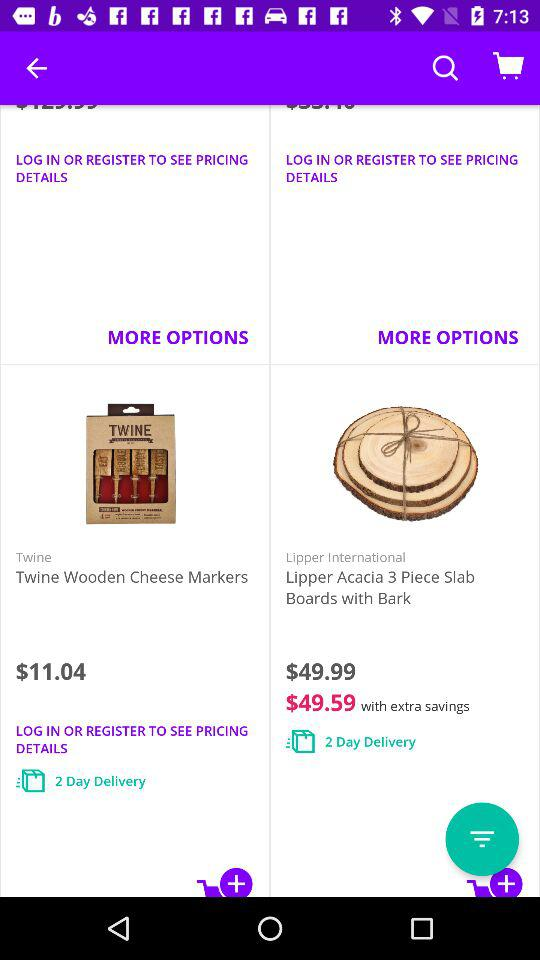How long will "Twine Wooden" take to deliver? "Twine Wooden" will take 2 days to deliver. 